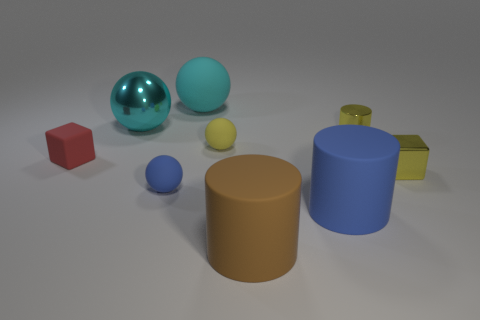Subtract all small blue rubber balls. How many balls are left? 3 Add 1 cyan rubber balls. How many objects exist? 10 Subtract all blue spheres. How many spheres are left? 3 Subtract 2 blocks. How many blocks are left? 0 Subtract all cyan cylinders. How many cyan balls are left? 2 Subtract all blocks. How many objects are left? 7 Subtract all metallic cubes. Subtract all tiny yellow shiny cubes. How many objects are left? 7 Add 2 small yellow rubber spheres. How many small yellow rubber spheres are left? 3 Add 6 small matte cubes. How many small matte cubes exist? 7 Subtract 0 purple spheres. How many objects are left? 9 